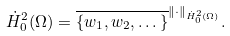<formula> <loc_0><loc_0><loc_500><loc_500>\dot { H } ^ { 2 } _ { 0 } ( \Omega ) = \overline { \{ w _ { 1 } , w _ { 2 } , \dots \} } ^ { \| \cdot \| _ { \dot { H } ^ { 2 } _ { 0 } ( \Omega ) } } .</formula> 